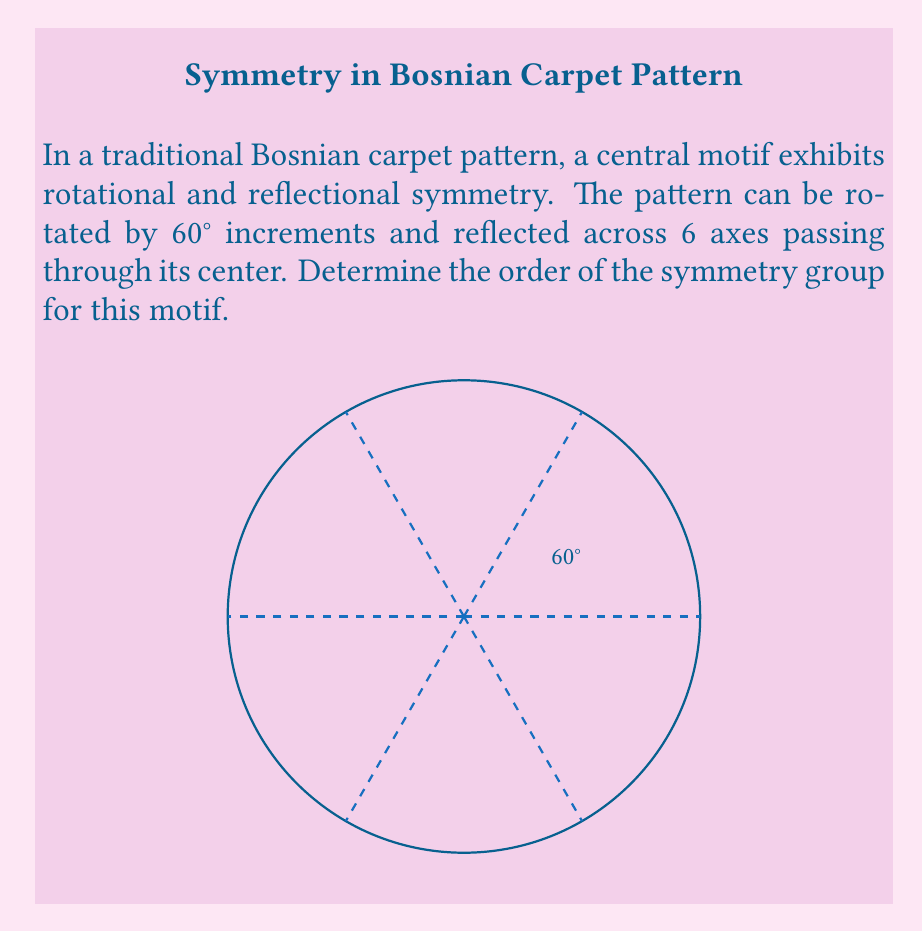Teach me how to tackle this problem. To determine the order of the symmetry group, we need to count all distinct symmetry operations:

1. Rotational symmetries:
   - The pattern can be rotated by 60°, 120°, 180°, 240°, 300°, and 360° (identity).
   - This gives 6 rotational symmetries.

2. Reflectional symmetries:
   - There are 6 axes of reflection.

3. Total number of symmetries:
   - The total number of symmetries is the sum of rotational and reflectional symmetries.
   - However, the identity (360° rotation) is counted twice, so we subtract 1.

Therefore, the order of the symmetry group is:

$$ \text{Order} = \text{Rotations} + \text{Reflections} - 1 $$
$$ \text{Order} = 6 + 6 - 1 = 11 $$

This symmetry group is known as the dihedral group $D_6$, which has order 12.

The significance of this pattern in Bosnian culture reflects the intricate geometric designs often found in Islamic art, which has been a part of Bosnian heritage for centuries. The symmetry in these patterns symbolizes harmony and unity, values that resonate deeply with those seeking to preserve and honor Bosnian cultural identity.
Answer: The order of the symmetry group for the given Bosnian carpet motif is 12. 